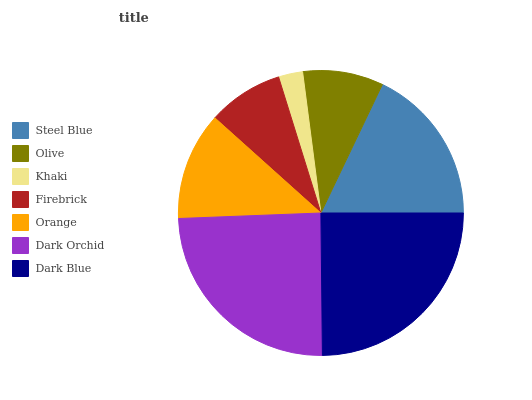Is Khaki the minimum?
Answer yes or no. Yes. Is Dark Blue the maximum?
Answer yes or no. Yes. Is Olive the minimum?
Answer yes or no. No. Is Olive the maximum?
Answer yes or no. No. Is Steel Blue greater than Olive?
Answer yes or no. Yes. Is Olive less than Steel Blue?
Answer yes or no. Yes. Is Olive greater than Steel Blue?
Answer yes or no. No. Is Steel Blue less than Olive?
Answer yes or no. No. Is Orange the high median?
Answer yes or no. Yes. Is Orange the low median?
Answer yes or no. Yes. Is Dark Orchid the high median?
Answer yes or no. No. Is Steel Blue the low median?
Answer yes or no. No. 